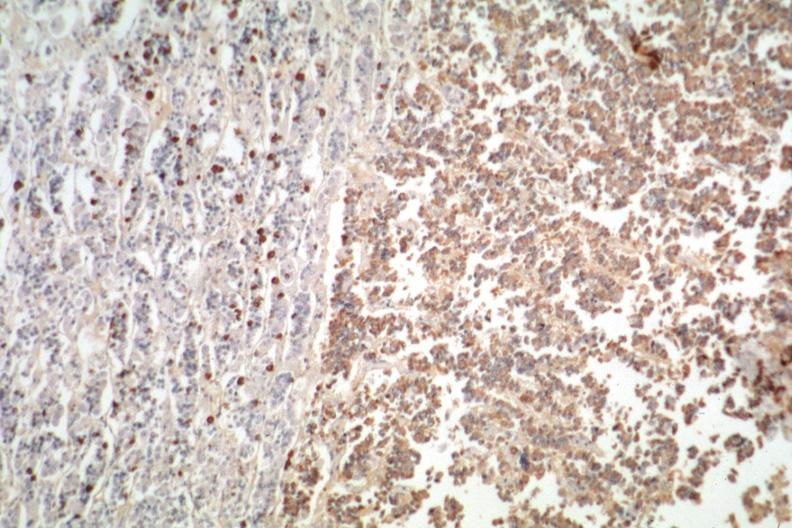what is present?
Answer the question using a single word or phrase. Pituitary 